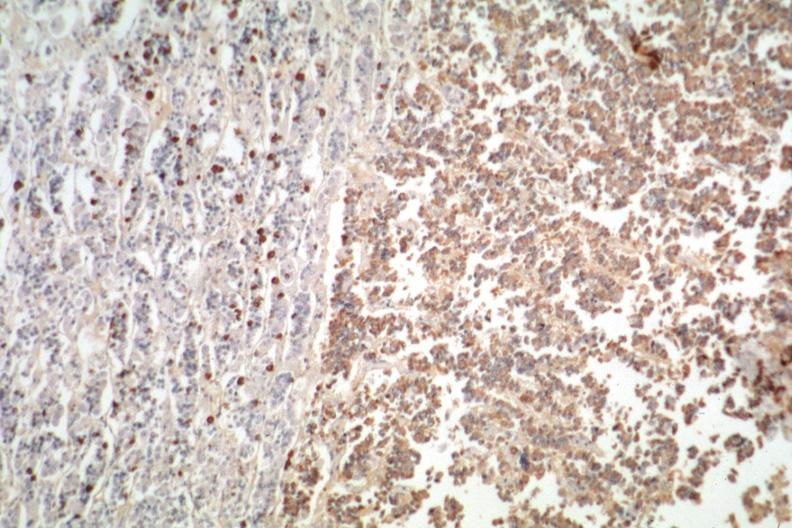what is present?
Answer the question using a single word or phrase. Pituitary 